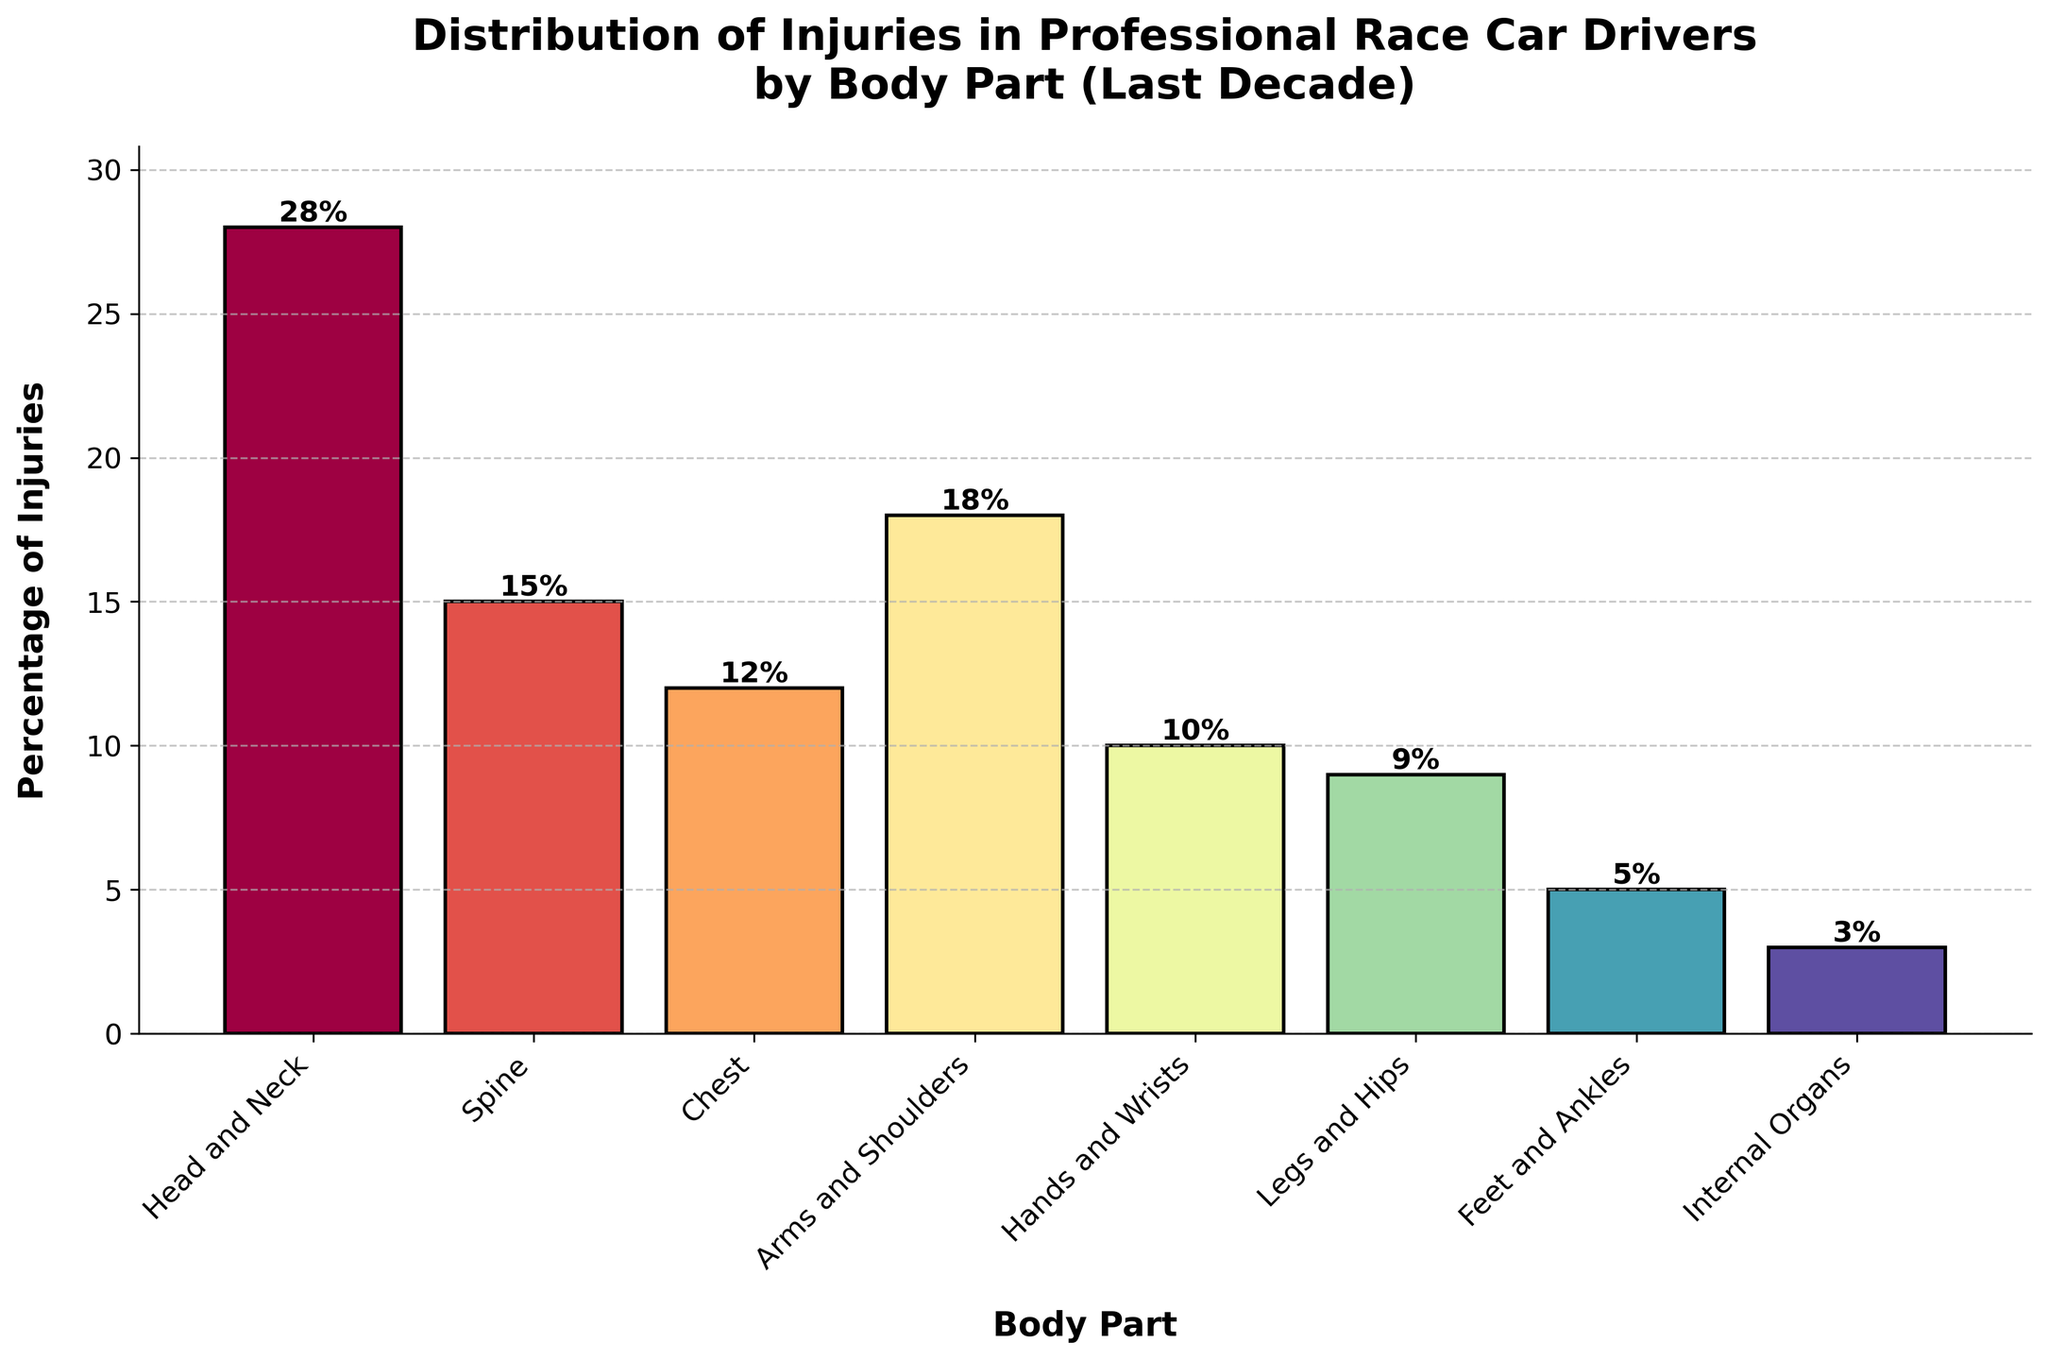Which body part has the highest percentage of injuries? The tallest bar in the chart represents the 'Head and Neck', indicating the highest percentage of injuries among professional race car drivers over the last decade.
Answer: Head and Neck Which body part has the lowest percentage of injuries? The shortest bar in the chart represents the 'Internal Organs', indicating the lowest percentage of injuries over the last decade.
Answer: Internal Organs What is the combined percentage of injuries for the Head and Neck, and Spine? Add the percentages of the Head and Neck (28%) and the Spine (15%), which equals 28% + 15% = 43%.
Answer: 43% How much higher is the percentage of injuries to the Arms and Shoulders compared to the Legs and Hips? Subtract the percentage of injuries to the Legs and Hips (9%) from the percentage of injuries to the Arms and Shoulders (18%), which equals 18% - 9% = 9%.
Answer: 9% What is the average percentage of injuries for Chest, Hands and Wrists, and Legs and Hips? Add the percentages of Chest (12%), Hands and Wrists (10%), and Legs and Hips (9%), then divide by 3. (12% + 10% + 9%)/3 = 31%/3 = 10.33%
Answer: 10.33% Which body part has more injuries: Chest or Feet and Ankles? Compare the heights of the bars for Chest (12%) and Feet and Ankles (5%). The Chest bar is taller.
Answer: Chest What is the difference in injury percentage between the Spine and Internal Organs? Subtract the percentage of Internal Organs injuries (3%) from the Spine injuries (15%), which equals 15% - 3% = 12%.
Answer: 12% What percentage of injuries are in areas below the waist (Legs and Hips, Feet and Ankles)? Add the percentages of Legs and Hips (9%) and Feet and Ankles (5%), which equals 9% + 5% = 14%.
Answer: 14% If you sum the percentages of injuries to the Arms and Shoulders and Chest, does it exceed the injuries to the Head and Neck? Add the percentages of Arms and Shoulders (18%) and Chest (12%), which equals 18% + 12% = 30%. Compare it to the Head and Neck which is 28%. 30% > 28%.
Answer: Yes In which order from highest to lowest are the percentages of injuries for Hands and Wrists, Legs and Hips, and Feet and Ankles? Refer to the heights of the respective bars: Hands and Wrists (10%), Legs and Hips (9%), Feet and Ankles (5%). So, the order is Hands and Wrists > Legs and Hips > Feet and Ankles.
Answer: Hands and Wrists, Legs and Hips, Feet and Ankles 